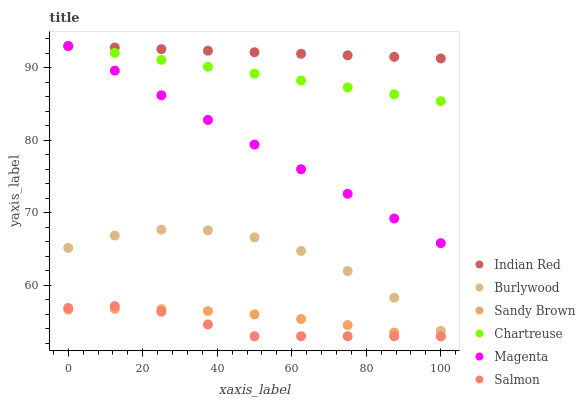Does Salmon have the minimum area under the curve?
Answer yes or no. Yes. Does Indian Red have the maximum area under the curve?
Answer yes or no. Yes. Does Chartreuse have the minimum area under the curve?
Answer yes or no. No. Does Chartreuse have the maximum area under the curve?
Answer yes or no. No. Is Chartreuse the smoothest?
Answer yes or no. Yes. Is Burlywood the roughest?
Answer yes or no. Yes. Is Salmon the smoothest?
Answer yes or no. No. Is Salmon the roughest?
Answer yes or no. No. Does Salmon have the lowest value?
Answer yes or no. Yes. Does Chartreuse have the lowest value?
Answer yes or no. No. Does Magenta have the highest value?
Answer yes or no. Yes. Does Salmon have the highest value?
Answer yes or no. No. Is Sandy Brown less than Indian Red?
Answer yes or no. Yes. Is Magenta greater than Sandy Brown?
Answer yes or no. Yes. Does Chartreuse intersect Indian Red?
Answer yes or no. Yes. Is Chartreuse less than Indian Red?
Answer yes or no. No. Is Chartreuse greater than Indian Red?
Answer yes or no. No. Does Sandy Brown intersect Indian Red?
Answer yes or no. No. 